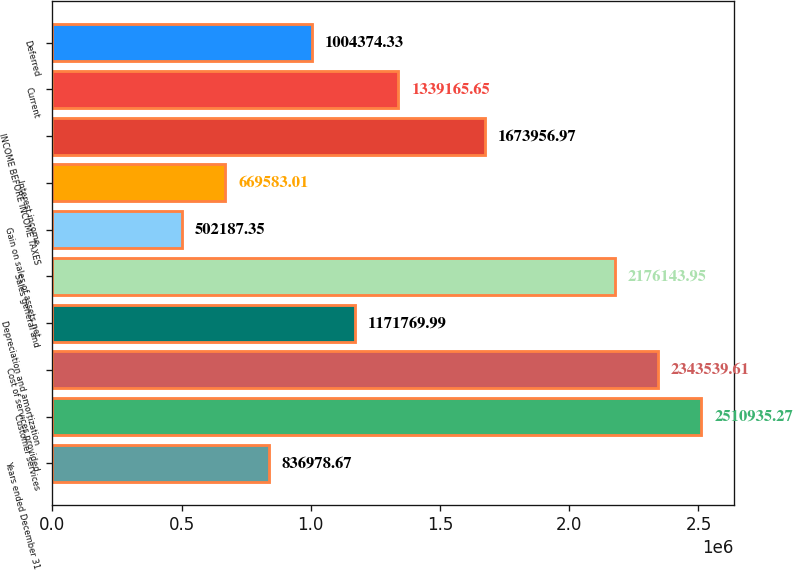Convert chart. <chart><loc_0><loc_0><loc_500><loc_500><bar_chart><fcel>Years ended December 31<fcel>Customer services<fcel>Cost of services provided<fcel>Depreciation and amortization<fcel>Sales general and<fcel>Gain on sales of assets net<fcel>Interest income<fcel>INCOME BEFORE INCOME TAXES<fcel>Current<fcel>Deferred<nl><fcel>836979<fcel>2.51094e+06<fcel>2.34354e+06<fcel>1.17177e+06<fcel>2.17614e+06<fcel>502187<fcel>669583<fcel>1.67396e+06<fcel>1.33917e+06<fcel>1.00437e+06<nl></chart> 